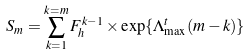Convert formula to latex. <formula><loc_0><loc_0><loc_500><loc_500>S _ { m } = \sum _ { k = 1 } ^ { k = m } F _ { h } ^ { k - 1 } \times \exp \{ \Lambda ^ { t } _ { \max } ( m - k ) \}</formula> 